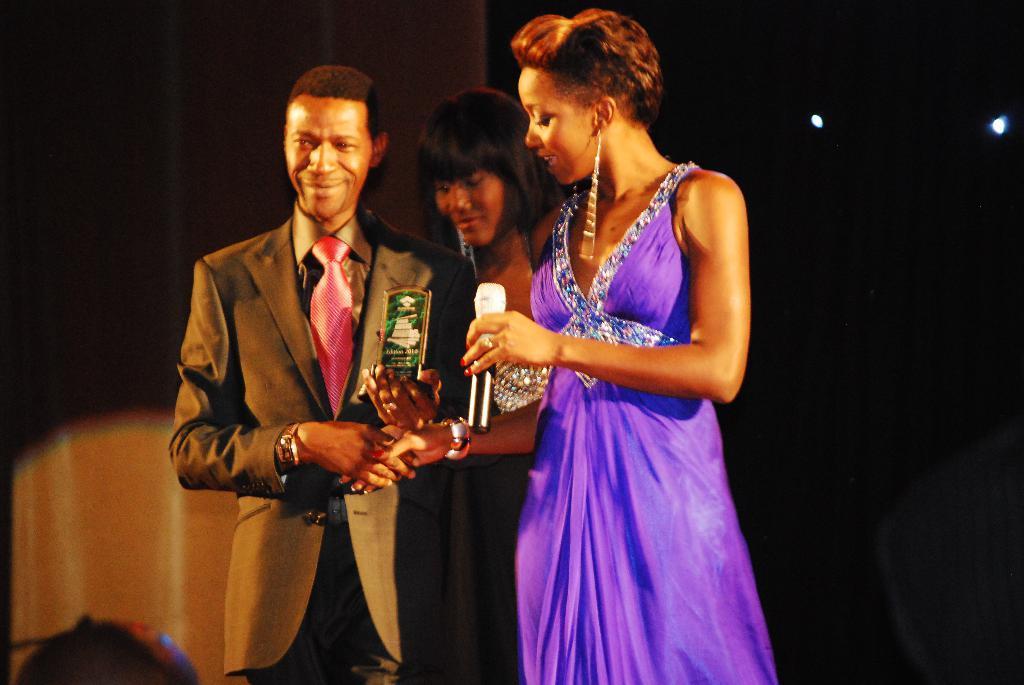Please provide a concise description of this image. There are three people standing and he is holding trophy and she is holding microphone. In the background it is dark and we can see lights. 